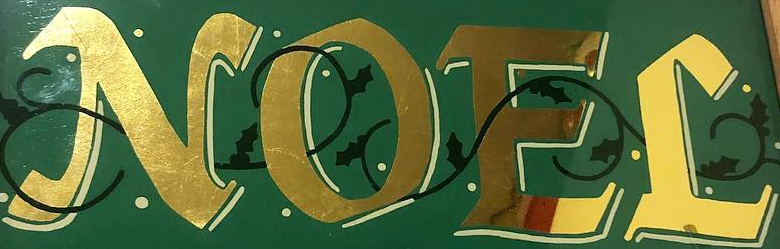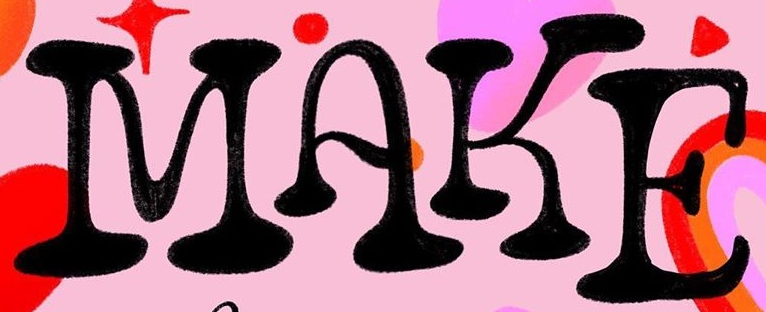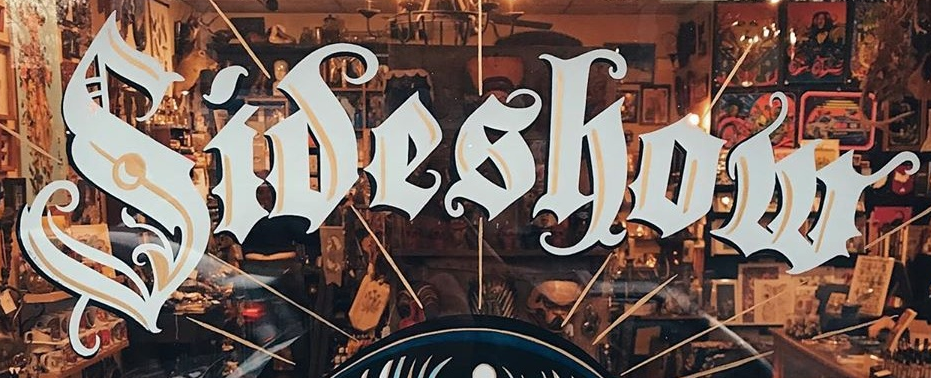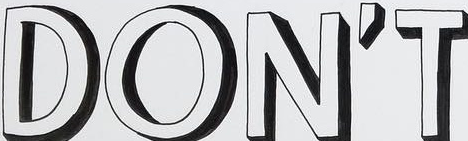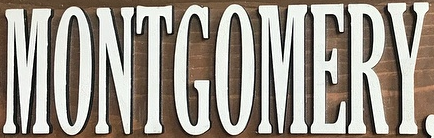Transcribe the words shown in these images in order, separated by a semicolon. NOEL; MAKE; Sideshow; DON'T; MONTGOMERY 